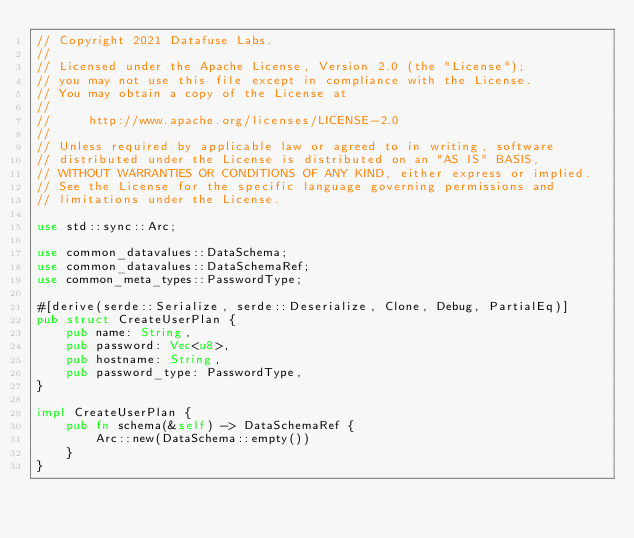<code> <loc_0><loc_0><loc_500><loc_500><_Rust_>// Copyright 2021 Datafuse Labs.
//
// Licensed under the Apache License, Version 2.0 (the "License");
// you may not use this file except in compliance with the License.
// You may obtain a copy of the License at
//
//     http://www.apache.org/licenses/LICENSE-2.0
//
// Unless required by applicable law or agreed to in writing, software
// distributed under the License is distributed on an "AS IS" BASIS,
// WITHOUT WARRANTIES OR CONDITIONS OF ANY KIND, either express or implied.
// See the License for the specific language governing permissions and
// limitations under the License.

use std::sync::Arc;

use common_datavalues::DataSchema;
use common_datavalues::DataSchemaRef;
use common_meta_types::PasswordType;

#[derive(serde::Serialize, serde::Deserialize, Clone, Debug, PartialEq)]
pub struct CreateUserPlan {
    pub name: String,
    pub password: Vec<u8>,
    pub hostname: String,
    pub password_type: PasswordType,
}

impl CreateUserPlan {
    pub fn schema(&self) -> DataSchemaRef {
        Arc::new(DataSchema::empty())
    }
}
</code> 